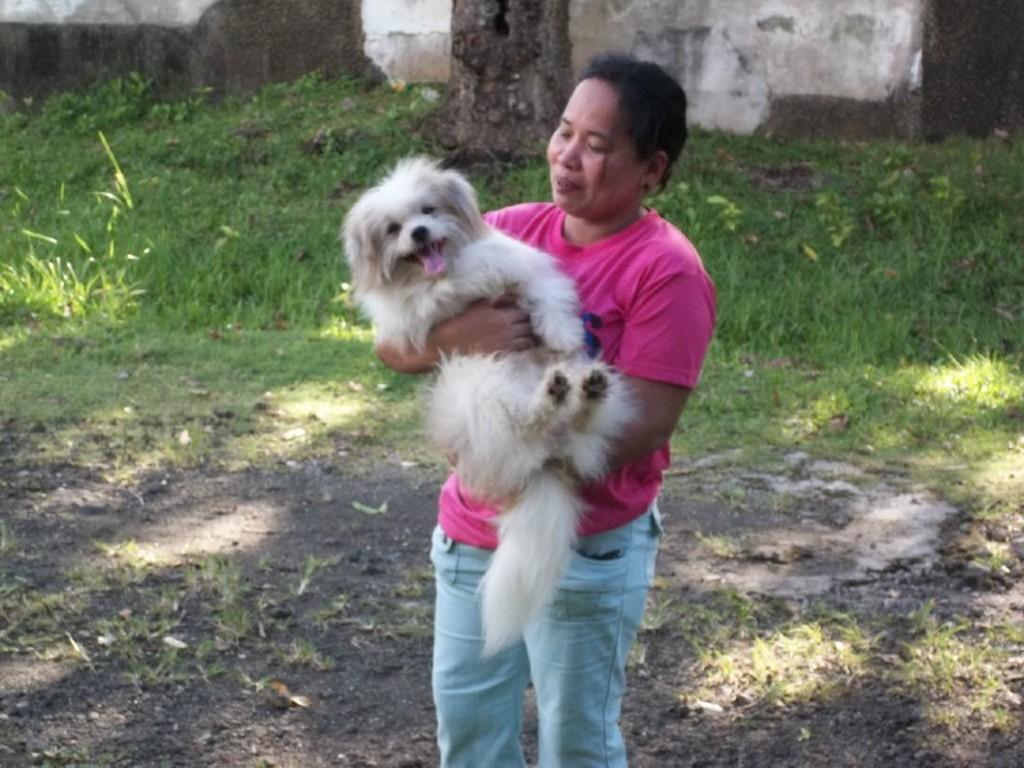In one or two sentences, can you explain what this image depicts? In the picture there is a woman wearing pink shirt she is holding a dog in her hand the dog is fluffy and white,on the floor there are some grass and soil,in the background there is a wall and a tree. 